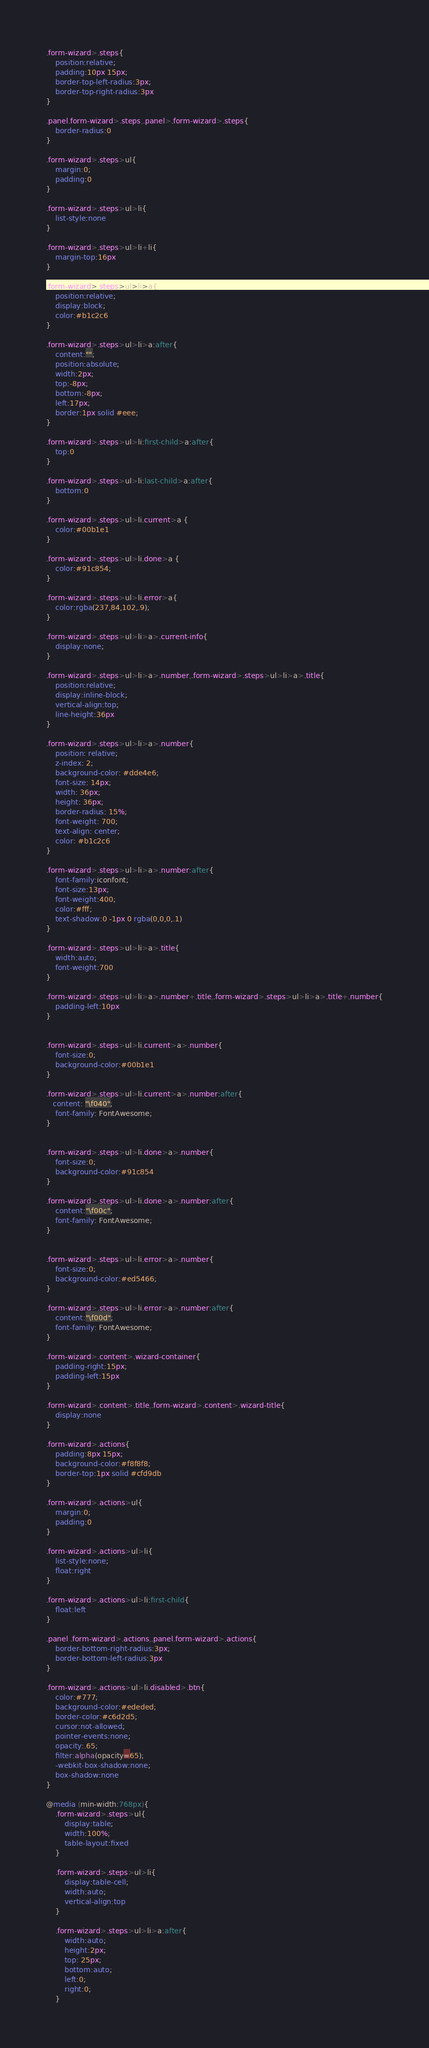<code> <loc_0><loc_0><loc_500><loc_500><_CSS_>.form-wizard>.steps{
	position:relative;
	padding:10px 15px;
	border-top-left-radius:3px;
	border-top-right-radius:3px
}

.panel.form-wizard>.steps,.panel>.form-wizard>.steps{
	border-radius:0
}

.form-wizard>.steps>ul{
	margin:0;
	padding:0
}

.form-wizard>.steps>ul>li{
	list-style:none
}

.form-wizard>.steps>ul>li+li{
	margin-top:16px
}

.form-wizard>.steps>ul>li>a{
	position:relative;
	display:block;
	color:#b1c2c6
}

.form-wizard>.steps>ul>li>a:after{
	content:"";
	position:absolute;
	width:2px;
	top:-8px;
	bottom:-8px;
	left:17px;
	border:1px solid #eee;
}

.form-wizard>.steps>ul>li:first-child>a:after{
	top:0
}

.form-wizard>.steps>ul>li:last-child>a:after{
	bottom:0
}

.form-wizard>.steps>ul>li.current>a {
	color:#00b1e1
}

.form-wizard>.steps>ul>li.done>a {
	color:#91c854;
}

.form-wizard>.steps>ul>li.error>a{
	color:rgba(237,84,102,.9);
}

.form-wizard>.steps>ul>li>a>.current-info{
	display:none;
}

.form-wizard>.steps>ul>li>a>.number,.form-wizard>.steps>ul>li>a>.title{
	position:relative;
	display:inline-block;
	vertical-align:top;
	line-height:36px
}

.form-wizard>.steps>ul>li>a>.number{
	position: relative;
	z-index: 2;
	background-color: #dde4e6;
	font-size: 14px;
	width: 36px;
	height: 36px;
	border-radius: 15%;
	font-weight: 700;
	text-align: center;
	color: #b1c2c6
}

.form-wizard>.steps>ul>li>a>.number:after{
	font-family:iconfont;
	font-size:13px;
	font-weight:400;
	color:#fff;
	text-shadow:0 -1px 0 rgba(0,0,0,.1)
}

.form-wizard>.steps>ul>li>a>.title{
	width:auto;
	font-weight:700
}

.form-wizard>.steps>ul>li>a>.number+.title,.form-wizard>.steps>ul>li>a>.title+.number{
	padding-left:10px
}


.form-wizard>.steps>ul>li.current>a>.number{
	font-size:0;
	background-color:#00b1e1
}

.form-wizard>.steps>ul>li.current>a>.number:after{
   content: "\f040";
	font-family: FontAwesome;
}


.form-wizard>.steps>ul>li.done>a>.number{
	font-size:0;
	background-color:#91c854
}

.form-wizard>.steps>ul>li.done>a>.number:after{
	content:"\f00c";
	font-family: FontAwesome;
}


.form-wizard>.steps>ul>li.error>a>.number{
	font-size:0;
	background-color:#ed5466;
}

.form-wizard>.steps>ul>li.error>a>.number:after{
	content:"\f00d";
	font-family: FontAwesome;
}

.form-wizard>.content>.wizard-container{
	padding-right:15px;
	padding-left:15px
}

.form-wizard>.content>.title,.form-wizard>.content>.wizard-title{
	display:none
}

.form-wizard>.actions{
	padding:8px 15px;
	background-color:#f8f8f8;
	border-top:1px solid #cfd9db
}

.form-wizard>.actions>ul{
	margin:0;
	padding:0
}

.form-wizard>.actions>ul>li{
	list-style:none;
	float:right
}

.form-wizard>.actions>ul>li:first-child{
	float:left
}

.panel .form-wizard>.actions,.panel.form-wizard>.actions{
	border-bottom-right-radius:3px;
	border-bottom-left-radius:3px
}

.form-wizard>.actions>ul>li.disabled>.btn{
	color:#777;
	background-color:#ededed;
	border-color:#c6d2d5;
	cursor:not-allowed;
	pointer-events:none;
	opacity:.65;
	filter:alpha(opacity=65);
	-webkit-box-shadow:none;
	box-shadow:none
}

@media (min-width:768px){
	.form-wizard>.steps>ul{
		display:table;
		width:100%;
		table-layout:fixed
	}

	.form-wizard>.steps>ul>li{
		display:table-cell;
		width:auto;
		vertical-align:top
	}

	.form-wizard>.steps>ul>li>a:after{
		width:auto;
		height:2px;
		top: 25px;
		bottom:auto;
		left:0;
		right:0;
	}
</code> 